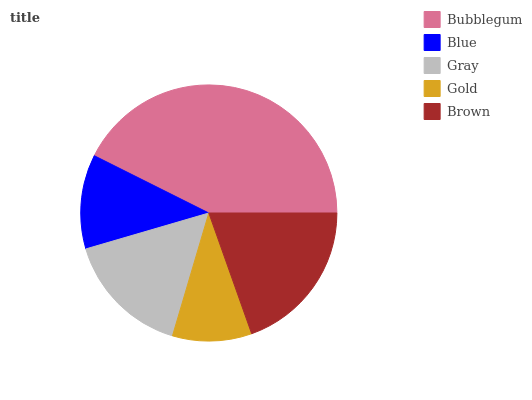Is Gold the minimum?
Answer yes or no. Yes. Is Bubblegum the maximum?
Answer yes or no. Yes. Is Blue the minimum?
Answer yes or no. No. Is Blue the maximum?
Answer yes or no. No. Is Bubblegum greater than Blue?
Answer yes or no. Yes. Is Blue less than Bubblegum?
Answer yes or no. Yes. Is Blue greater than Bubblegum?
Answer yes or no. No. Is Bubblegum less than Blue?
Answer yes or no. No. Is Gray the high median?
Answer yes or no. Yes. Is Gray the low median?
Answer yes or no. Yes. Is Brown the high median?
Answer yes or no. No. Is Bubblegum the low median?
Answer yes or no. No. 